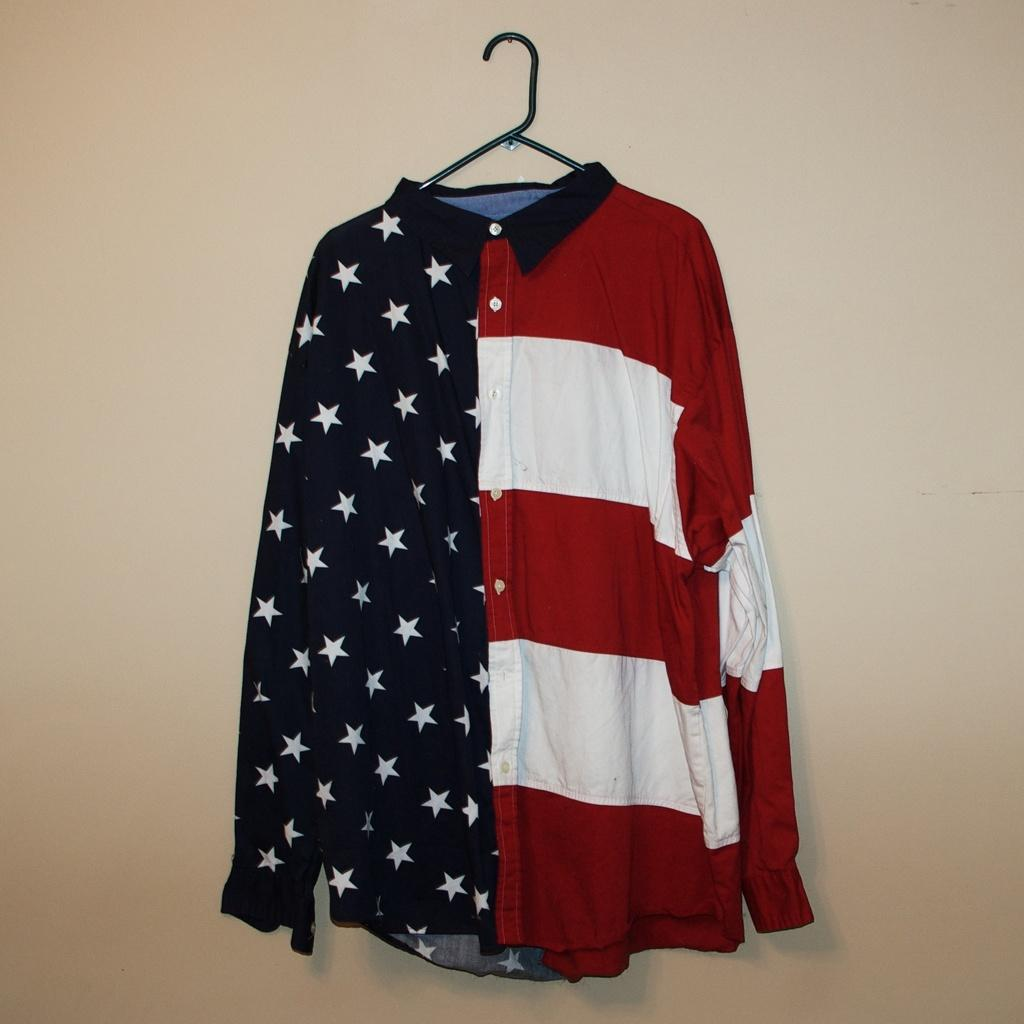What type of clothing item is in the image? There is a shirt in the image. What colors can be seen on the shirt? The shirt is white, red, and black in color. How is the shirt positioned in the image? The shirt is hanging on a hanger. What color is the wall in the background of the image? There is a cream-colored wall in the image. What type of creature is sitting on the shirt in the image? There is no creature present in the image. The shirt is hanging on a hanger, and there are no other objects or creatures visible. 